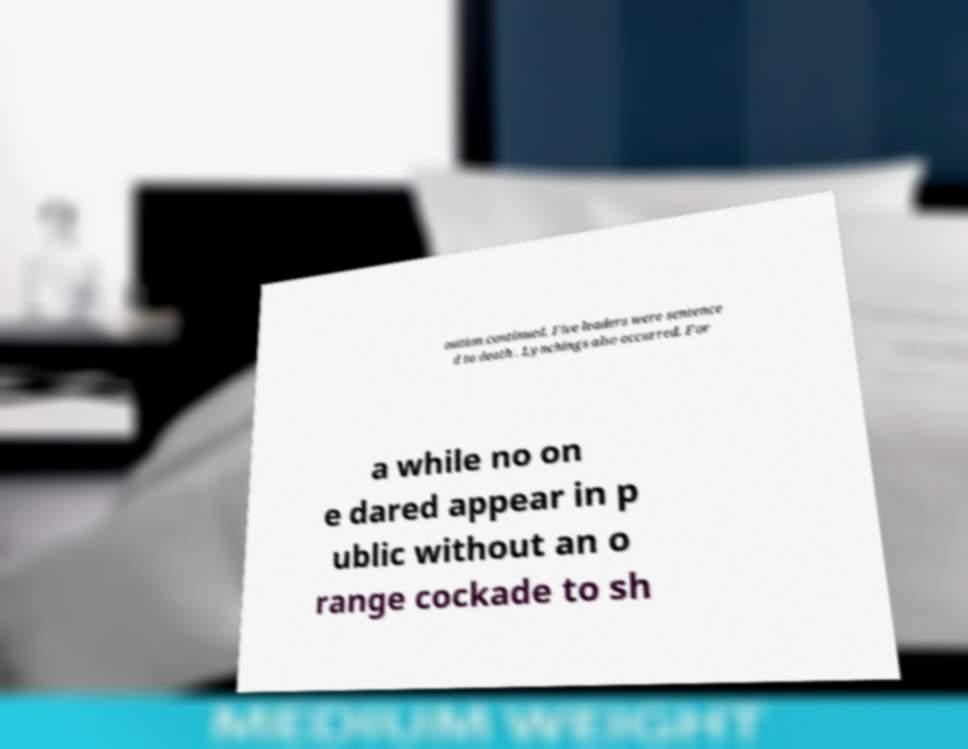Can you accurately transcribe the text from the provided image for me? osition continued. Five leaders were sentence d to death . Lynchings also occurred. For a while no on e dared appear in p ublic without an o range cockade to sh 